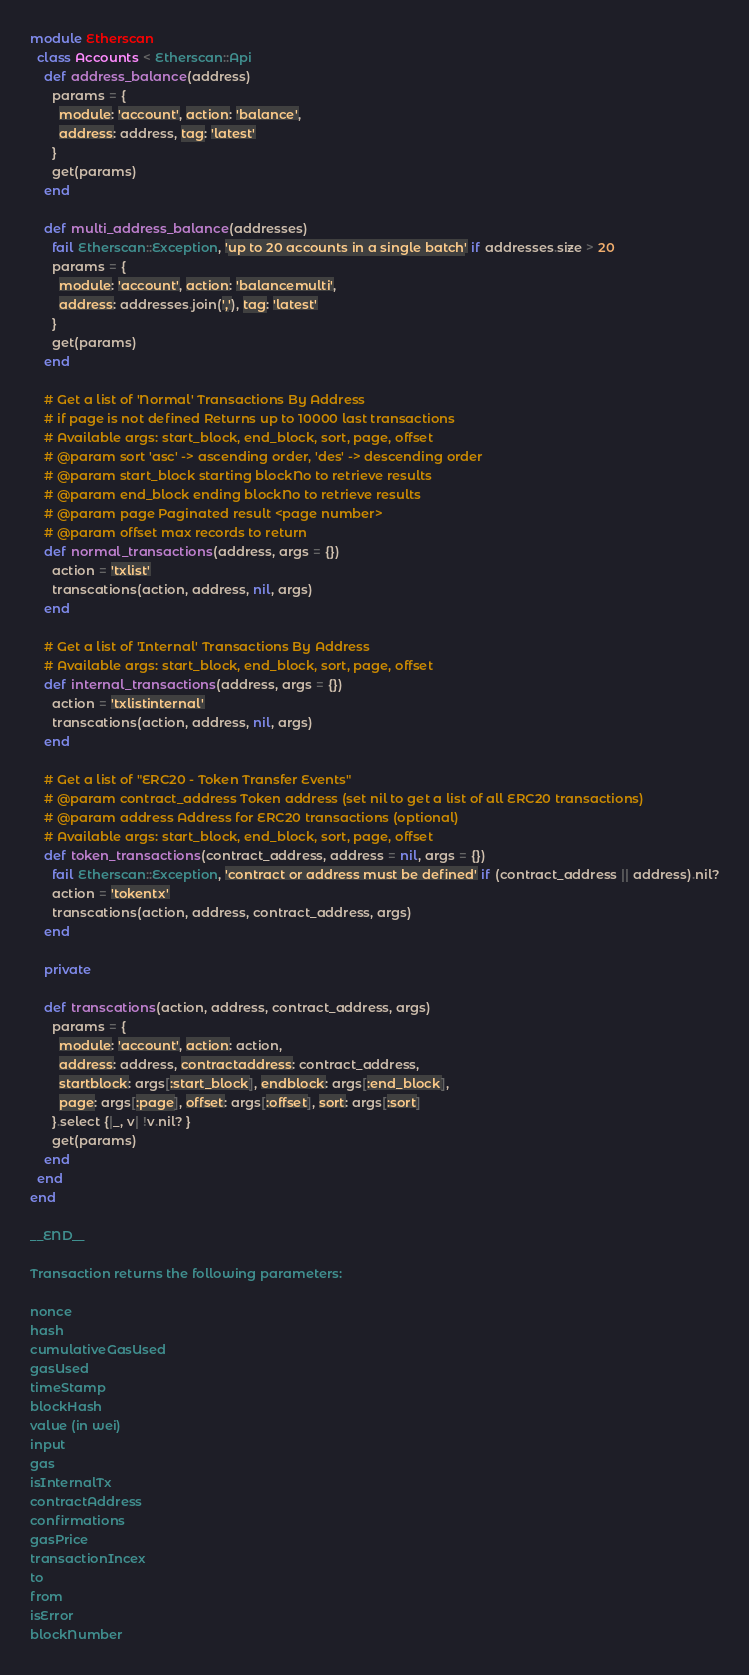<code> <loc_0><loc_0><loc_500><loc_500><_Ruby_>
module Etherscan
  class Accounts < Etherscan::Api
    def address_balance(address)
      params = {
        module: 'account', action: 'balance',
        address: address, tag: 'latest'
      }
      get(params)
    end

    def multi_address_balance(addresses)
      fail Etherscan::Exception, 'up to 20 accounts in a single batch' if addresses.size > 20
      params = {
        module: 'account', action: 'balancemulti',
        address: addresses.join(','), tag: 'latest'
      }
      get(params)
    end

    # Get a list of 'Normal' Transactions By Address
    # if page is not defined Returns up to 10000 last transactions
    # Available args: start_block, end_block, sort, page, offset
    # @param sort 'asc' -> ascending order, 'des' -> descending order
    # @param start_block starting blockNo to retrieve results
    # @param end_block ending blockNo to retrieve results
    # @param page Paginated result <page number>
    # @param offset max records to return
    def normal_transactions(address, args = {})
      action = 'txlist'
      transcations(action, address, nil, args)
    end

    # Get a list of 'Internal' Transactions By Address
    # Available args: start_block, end_block, sort, page, offset
    def internal_transactions(address, args = {})
      action = 'txlistinternal'
      transcations(action, address, nil, args)
    end

    # Get a list of "ERC20 - Token Transfer Events"
    # @param contract_address Token address (set nil to get a list of all ERC20 transactions)
    # @param address Address for ERC20 transactions (optional)
    # Available args: start_block, end_block, sort, page, offset
    def token_transactions(contract_address, address = nil, args = {})
      fail Etherscan::Exception, 'contract or address must be defined' if (contract_address || address).nil?
      action = 'tokentx'
      transcations(action, address, contract_address, args)
    end

    private

    def transcations(action, address, contract_address, args)
      params = {
        module: 'account', action: action,
        address: address, contractaddress: contract_address,
        startblock: args[:start_block], endblock: args[:end_block],
        page: args[:page], offset: args[:offset], sort: args[:sort]
      }.select {|_, v| !v.nil? }
      get(params)
    end
  end
end

__END__

Transaction returns the following parameters:

nonce
hash
cumulativeGasUsed
gasUsed
timeStamp
blockHash
value (in wei)
input
gas
isInternalTx
contractAddress
confirmations
gasPrice
transactionIncex
to
from
isError
blockNumber
</code> 